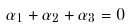Convert formula to latex. <formula><loc_0><loc_0><loc_500><loc_500>\alpha _ { 1 } + \alpha _ { 2 } + \alpha _ { 3 } = 0</formula> 